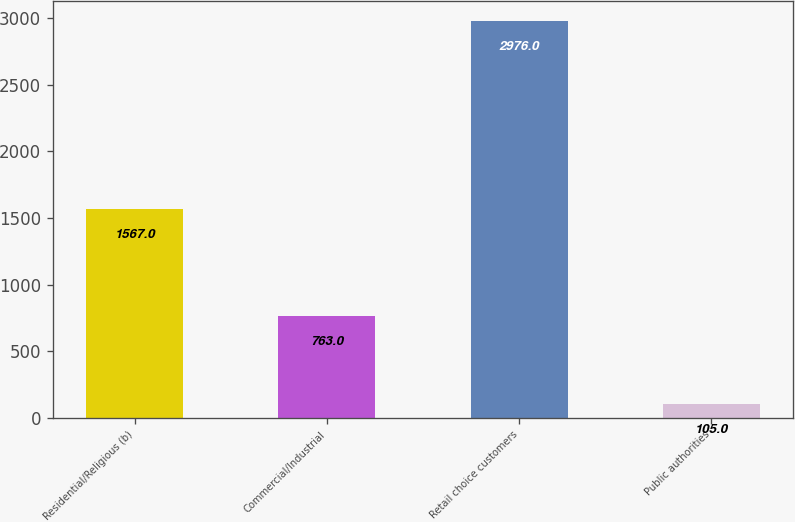Convert chart. <chart><loc_0><loc_0><loc_500><loc_500><bar_chart><fcel>Residential/Religious (b)<fcel>Commercial/Industrial<fcel>Retail choice customers<fcel>Public authorities<nl><fcel>1567<fcel>763<fcel>2976<fcel>105<nl></chart> 